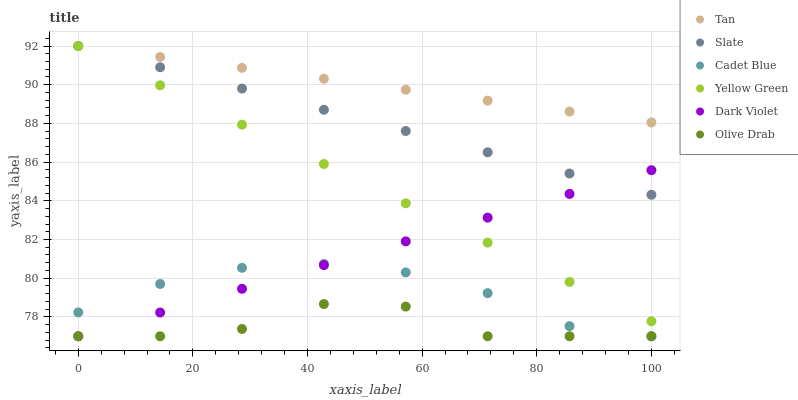Does Olive Drab have the minimum area under the curve?
Answer yes or no. Yes. Does Tan have the maximum area under the curve?
Answer yes or no. Yes. Does Yellow Green have the minimum area under the curve?
Answer yes or no. No. Does Yellow Green have the maximum area under the curve?
Answer yes or no. No. Is Tan the smoothest?
Answer yes or no. Yes. Is Olive Drab the roughest?
Answer yes or no. Yes. Is Yellow Green the smoothest?
Answer yes or no. No. Is Yellow Green the roughest?
Answer yes or no. No. Does Cadet Blue have the lowest value?
Answer yes or no. Yes. Does Yellow Green have the lowest value?
Answer yes or no. No. Does Tan have the highest value?
Answer yes or no. Yes. Does Dark Violet have the highest value?
Answer yes or no. No. Is Cadet Blue less than Slate?
Answer yes or no. Yes. Is Yellow Green greater than Olive Drab?
Answer yes or no. Yes. Does Dark Violet intersect Slate?
Answer yes or no. Yes. Is Dark Violet less than Slate?
Answer yes or no. No. Is Dark Violet greater than Slate?
Answer yes or no. No. Does Cadet Blue intersect Slate?
Answer yes or no. No. 